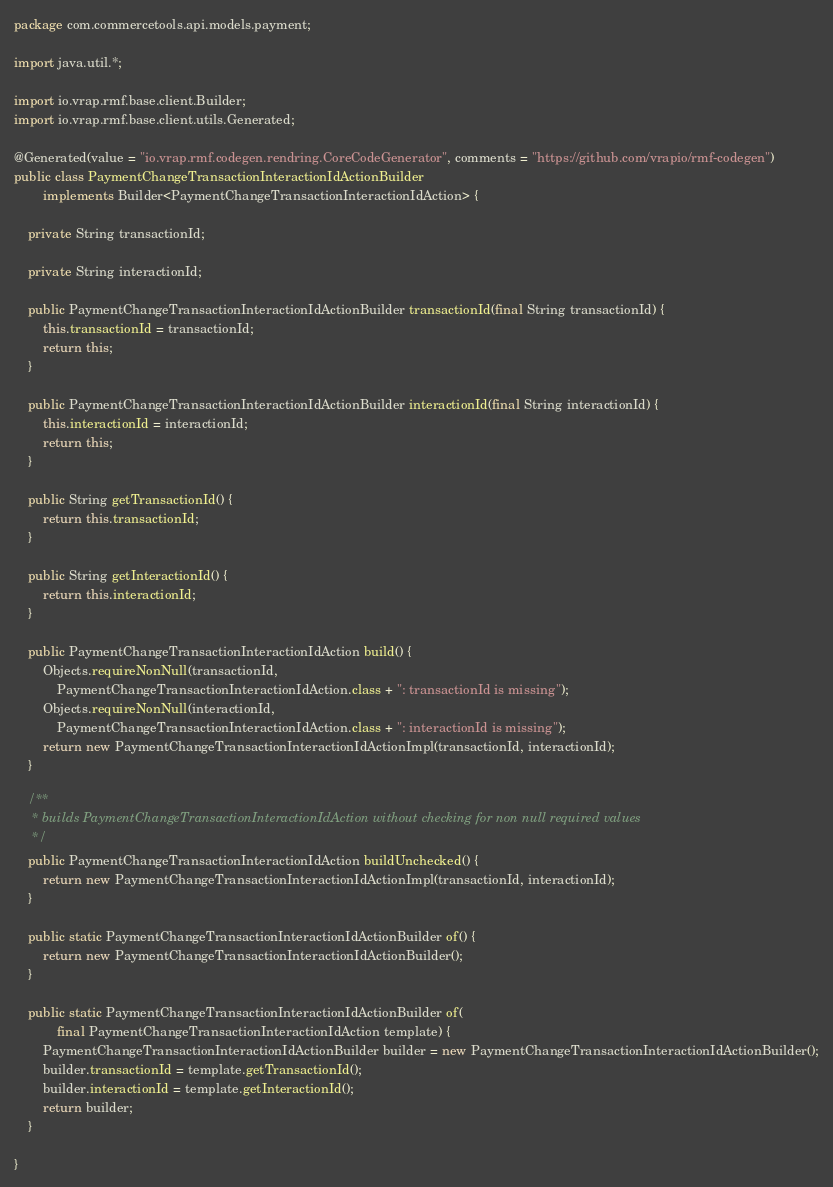Convert code to text. <code><loc_0><loc_0><loc_500><loc_500><_Java_>
package com.commercetools.api.models.payment;

import java.util.*;

import io.vrap.rmf.base.client.Builder;
import io.vrap.rmf.base.client.utils.Generated;

@Generated(value = "io.vrap.rmf.codegen.rendring.CoreCodeGenerator", comments = "https://github.com/vrapio/rmf-codegen")
public class PaymentChangeTransactionInteractionIdActionBuilder
        implements Builder<PaymentChangeTransactionInteractionIdAction> {

    private String transactionId;

    private String interactionId;

    public PaymentChangeTransactionInteractionIdActionBuilder transactionId(final String transactionId) {
        this.transactionId = transactionId;
        return this;
    }

    public PaymentChangeTransactionInteractionIdActionBuilder interactionId(final String interactionId) {
        this.interactionId = interactionId;
        return this;
    }

    public String getTransactionId() {
        return this.transactionId;
    }

    public String getInteractionId() {
        return this.interactionId;
    }

    public PaymentChangeTransactionInteractionIdAction build() {
        Objects.requireNonNull(transactionId,
            PaymentChangeTransactionInteractionIdAction.class + ": transactionId is missing");
        Objects.requireNonNull(interactionId,
            PaymentChangeTransactionInteractionIdAction.class + ": interactionId is missing");
        return new PaymentChangeTransactionInteractionIdActionImpl(transactionId, interactionId);
    }

    /**
     * builds PaymentChangeTransactionInteractionIdAction without checking for non null required values
     */
    public PaymentChangeTransactionInteractionIdAction buildUnchecked() {
        return new PaymentChangeTransactionInteractionIdActionImpl(transactionId, interactionId);
    }

    public static PaymentChangeTransactionInteractionIdActionBuilder of() {
        return new PaymentChangeTransactionInteractionIdActionBuilder();
    }

    public static PaymentChangeTransactionInteractionIdActionBuilder of(
            final PaymentChangeTransactionInteractionIdAction template) {
        PaymentChangeTransactionInteractionIdActionBuilder builder = new PaymentChangeTransactionInteractionIdActionBuilder();
        builder.transactionId = template.getTransactionId();
        builder.interactionId = template.getInteractionId();
        return builder;
    }

}
</code> 